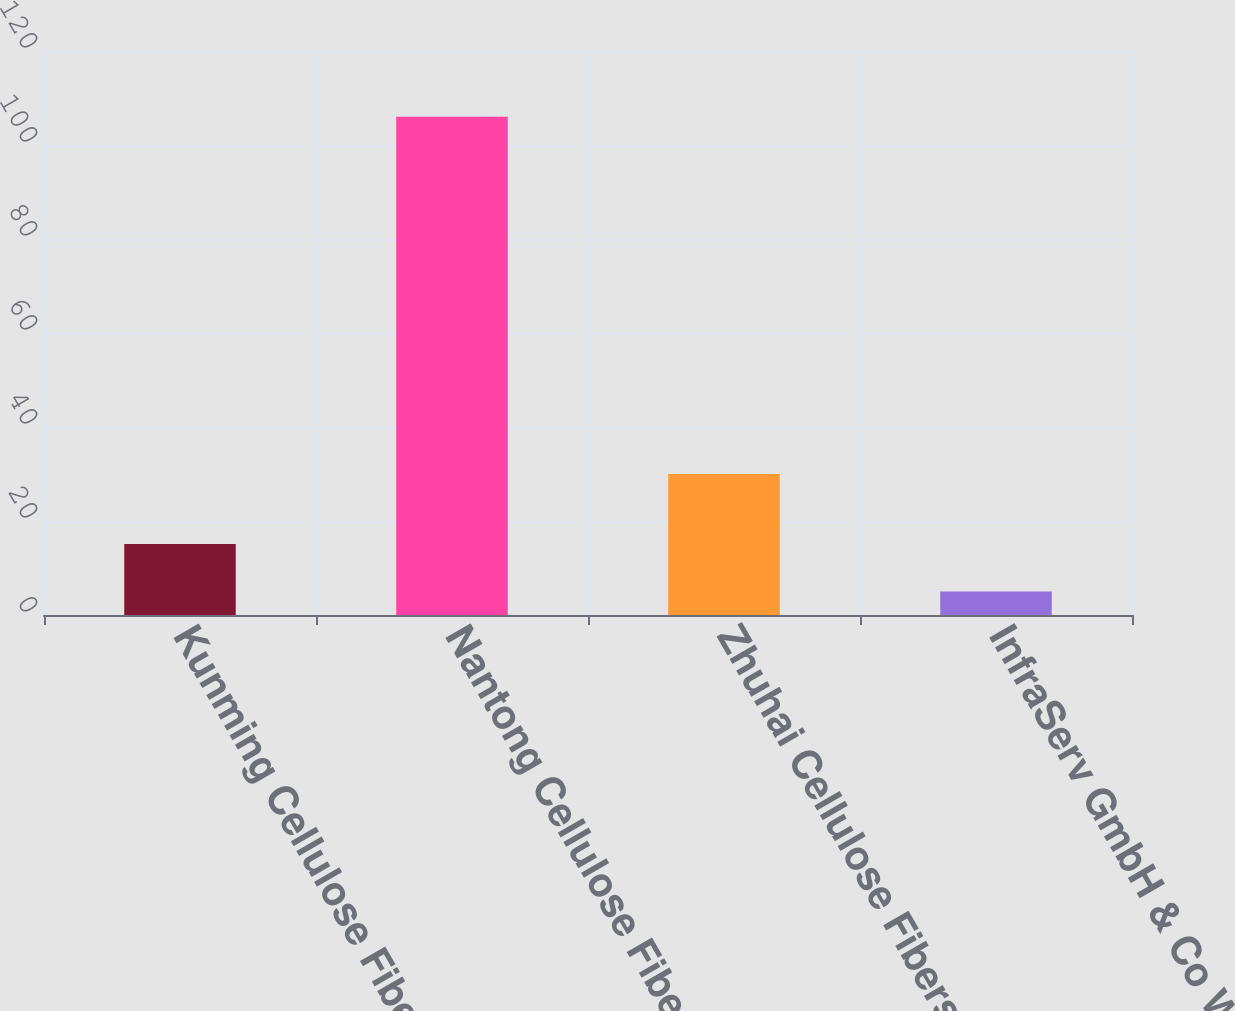Convert chart. <chart><loc_0><loc_0><loc_500><loc_500><bar_chart><fcel>Kunming Cellulose Fibers Co<fcel>Nantong Cellulose Fibers Co<fcel>Zhuhai Cellulose Fibers Co Ltd<fcel>InfraServ GmbH & Co Wiesbaden<nl><fcel>15.1<fcel>106<fcel>30<fcel>5<nl></chart> 